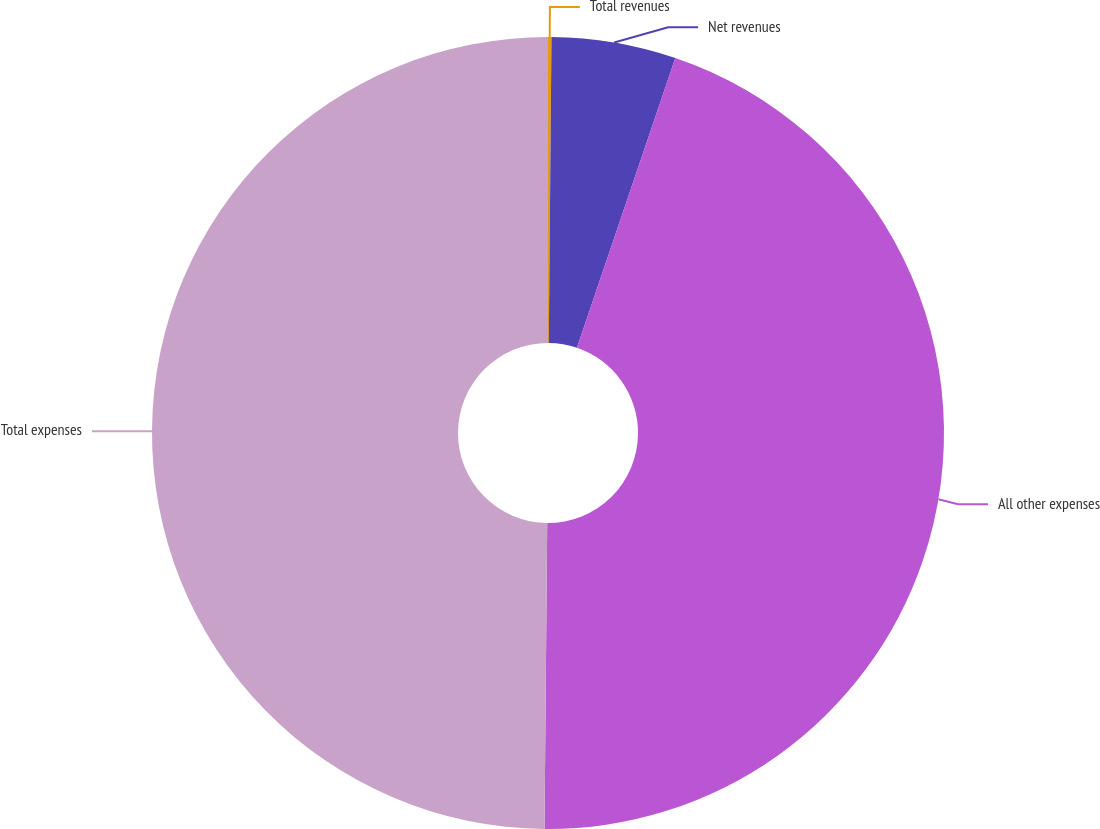<chart> <loc_0><loc_0><loc_500><loc_500><pie_chart><fcel>Total revenues<fcel>Net revenues<fcel>All other expenses<fcel>Total expenses<nl><fcel>0.14%<fcel>5.07%<fcel>44.93%<fcel>49.86%<nl></chart> 